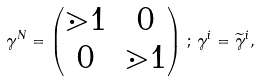Convert formula to latex. <formula><loc_0><loc_0><loc_500><loc_500>\gamma ^ { N } = \begin{pmatrix} \mathbb { m } { 1 } & 0 \\ 0 & \mathbb { m } { 1 } \\ \end{pmatrix} \, ; \, \gamma ^ { i } = \widetilde { \gamma } ^ { i } , \\</formula> 